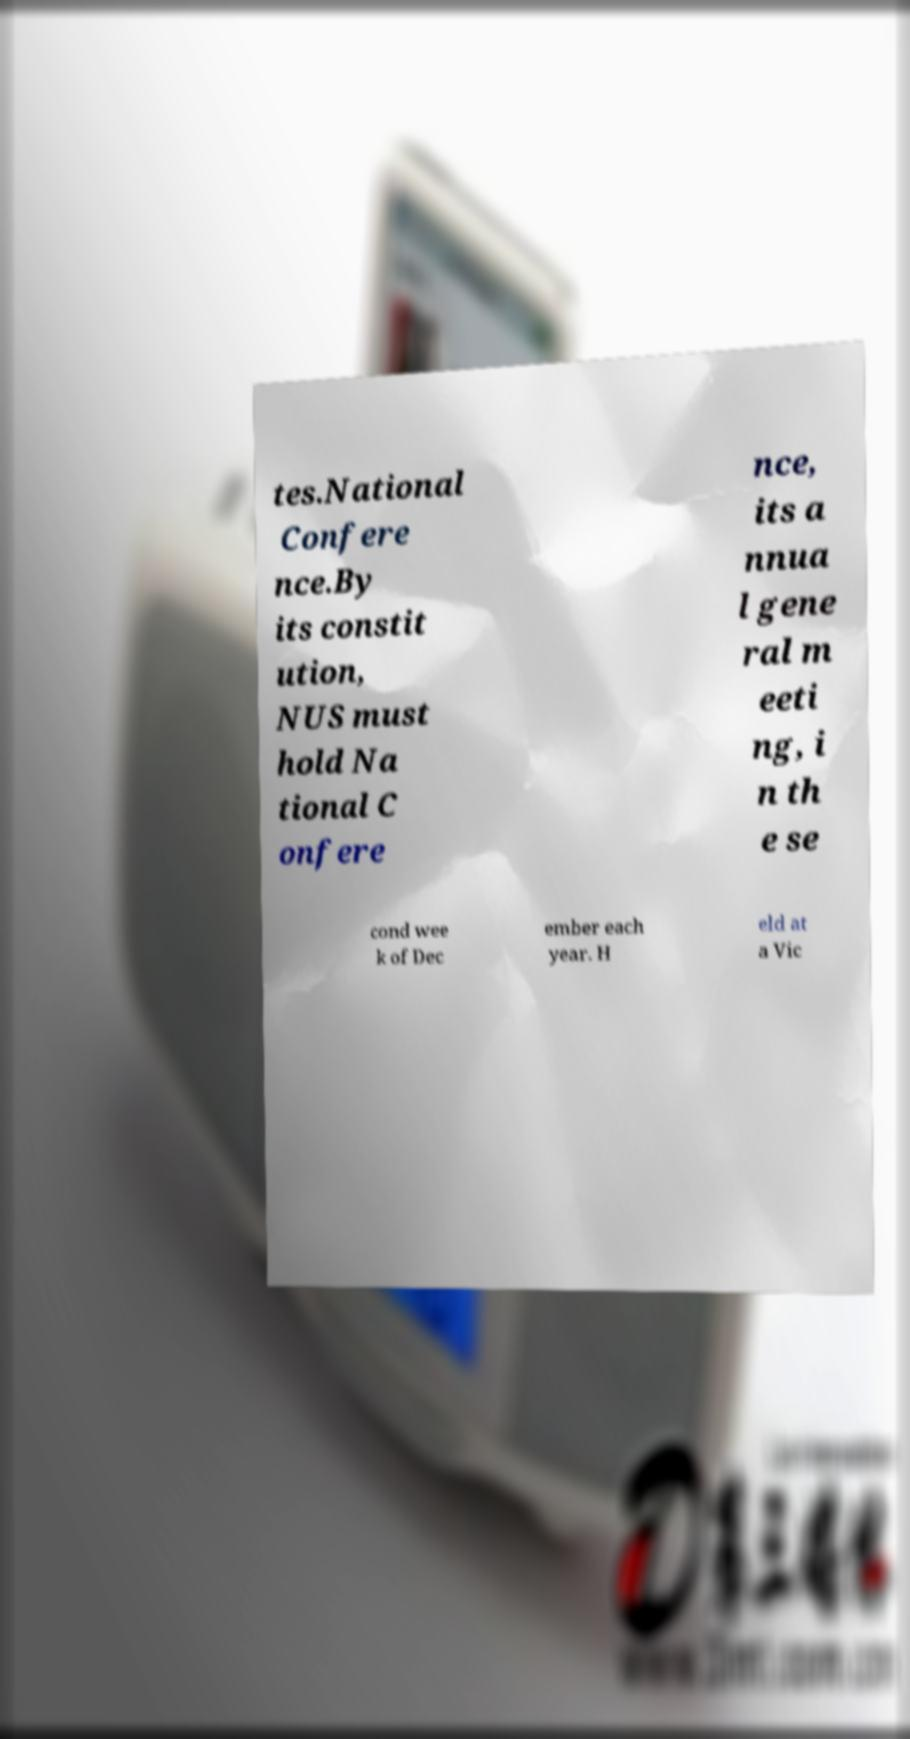Could you assist in decoding the text presented in this image and type it out clearly? tes.National Confere nce.By its constit ution, NUS must hold Na tional C onfere nce, its a nnua l gene ral m eeti ng, i n th e se cond wee k of Dec ember each year. H eld at a Vic 